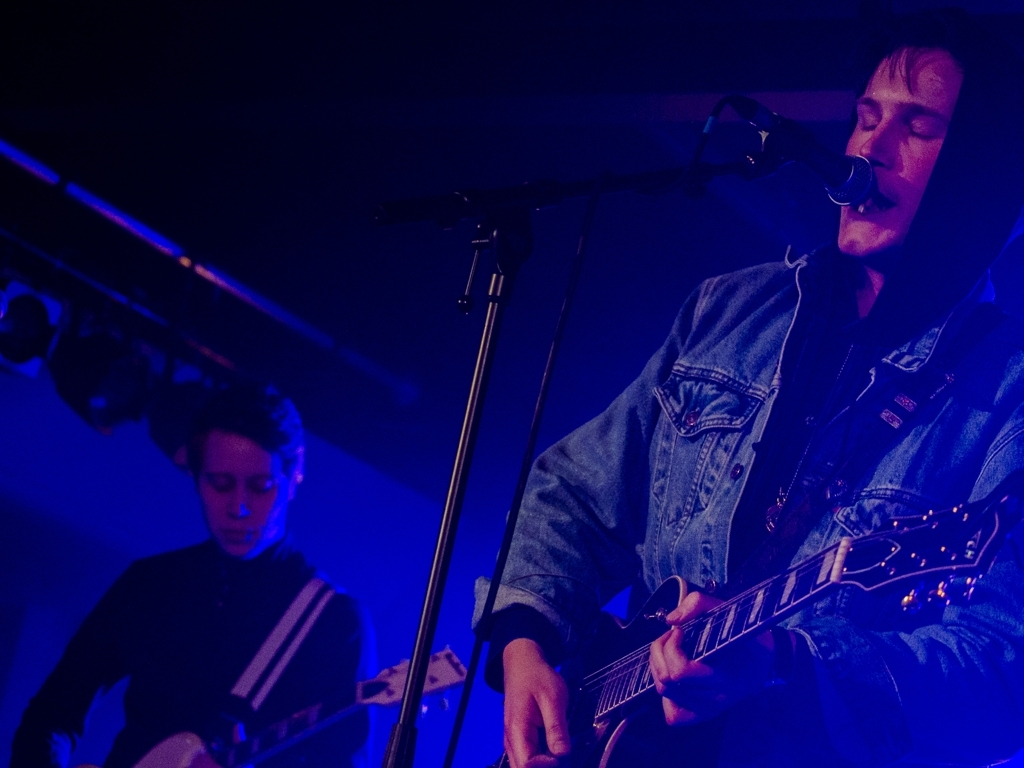Can you tell me what the mood of this scene might be? The mood of the scene is evocative of an intimate concert setting with a contemplative and immersive atmosphere. The subdued lighting and the musicians' focused expressions convey a sense of serious engagement with the music. 